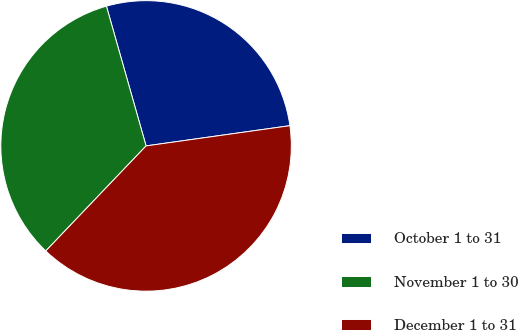<chart> <loc_0><loc_0><loc_500><loc_500><pie_chart><fcel>October 1 to 31<fcel>November 1 to 30<fcel>December 1 to 31<nl><fcel>27.18%<fcel>33.47%<fcel>39.36%<nl></chart> 